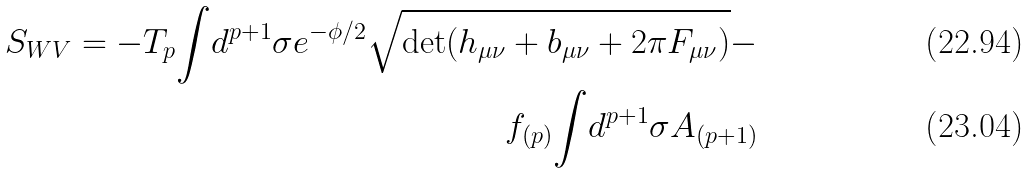Convert formula to latex. <formula><loc_0><loc_0><loc_500><loc_500>S _ { W V } = - T _ { p } { \int } d ^ { p + 1 } \sigma e ^ { - { \phi } / 2 } \sqrt { \det ( h _ { \mu \nu } + b _ { \mu \nu } + 2 \pi F _ { \mu \nu } ) } - \\ f _ { ( p ) } { \int } d ^ { p + 1 } \sigma A _ { ( p + 1 ) }</formula> 